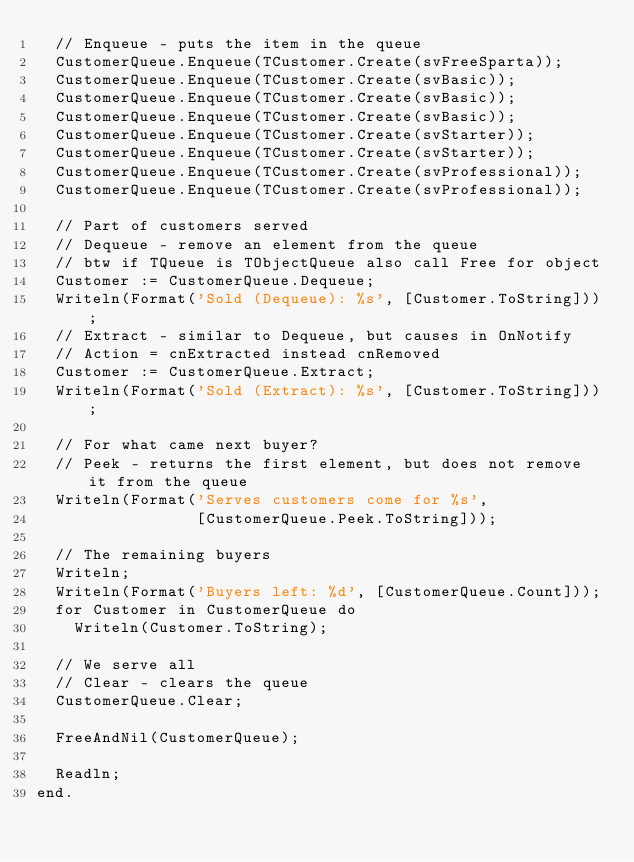<code> <loc_0><loc_0><loc_500><loc_500><_Pascal_>  // Enqueue - puts the item in the queue
  CustomerQueue.Enqueue(TCustomer.Create(svFreeSparta));
  CustomerQueue.Enqueue(TCustomer.Create(svBasic));
  CustomerQueue.Enqueue(TCustomer.Create(svBasic));
  CustomerQueue.Enqueue(TCustomer.Create(svBasic));
  CustomerQueue.Enqueue(TCustomer.Create(svStarter));
  CustomerQueue.Enqueue(TCustomer.Create(svStarter));
  CustomerQueue.Enqueue(TCustomer.Create(svProfessional));
  CustomerQueue.Enqueue(TCustomer.Create(svProfessional));

  // Part of customers served
  // Dequeue - remove an element from the queue
  // btw if TQueue is TObjectQueue also call Free for object
  Customer := CustomerQueue.Dequeue;
  Writeln(Format('Sold (Dequeue): %s', [Customer.ToString]));
  // Extract - similar to Dequeue, but causes in OnNotify
  // Action = cnExtracted instead cnRemoved
  Customer := CustomerQueue.Extract;
  Writeln(Format('Sold (Extract): %s', [Customer.ToString]));

  // For what came next buyer?
  // Peek - returns the first element, but does not remove it from the queue
  Writeln(Format('Serves customers come for %s',
                 [CustomerQueue.Peek.ToString]));

  // The remaining buyers
  Writeln;
  Writeln(Format('Buyers left: %d', [CustomerQueue.Count]));
  for Customer in CustomerQueue do
    Writeln(Customer.ToString);

  // We serve all
  // Clear - clears the queue
  CustomerQueue.Clear;

  FreeAndNil(CustomerQueue);

  Readln;
end.

</code> 